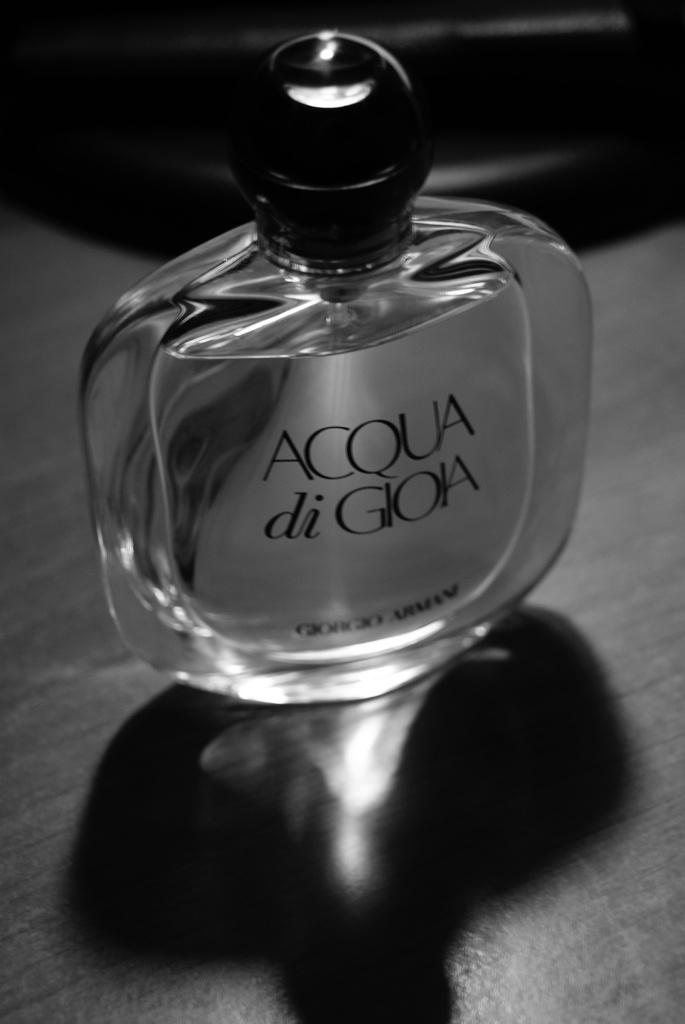<image>
Offer a succinct explanation of the picture presented. A bottle of Acqua di Gioia cologne on a wooden table. 